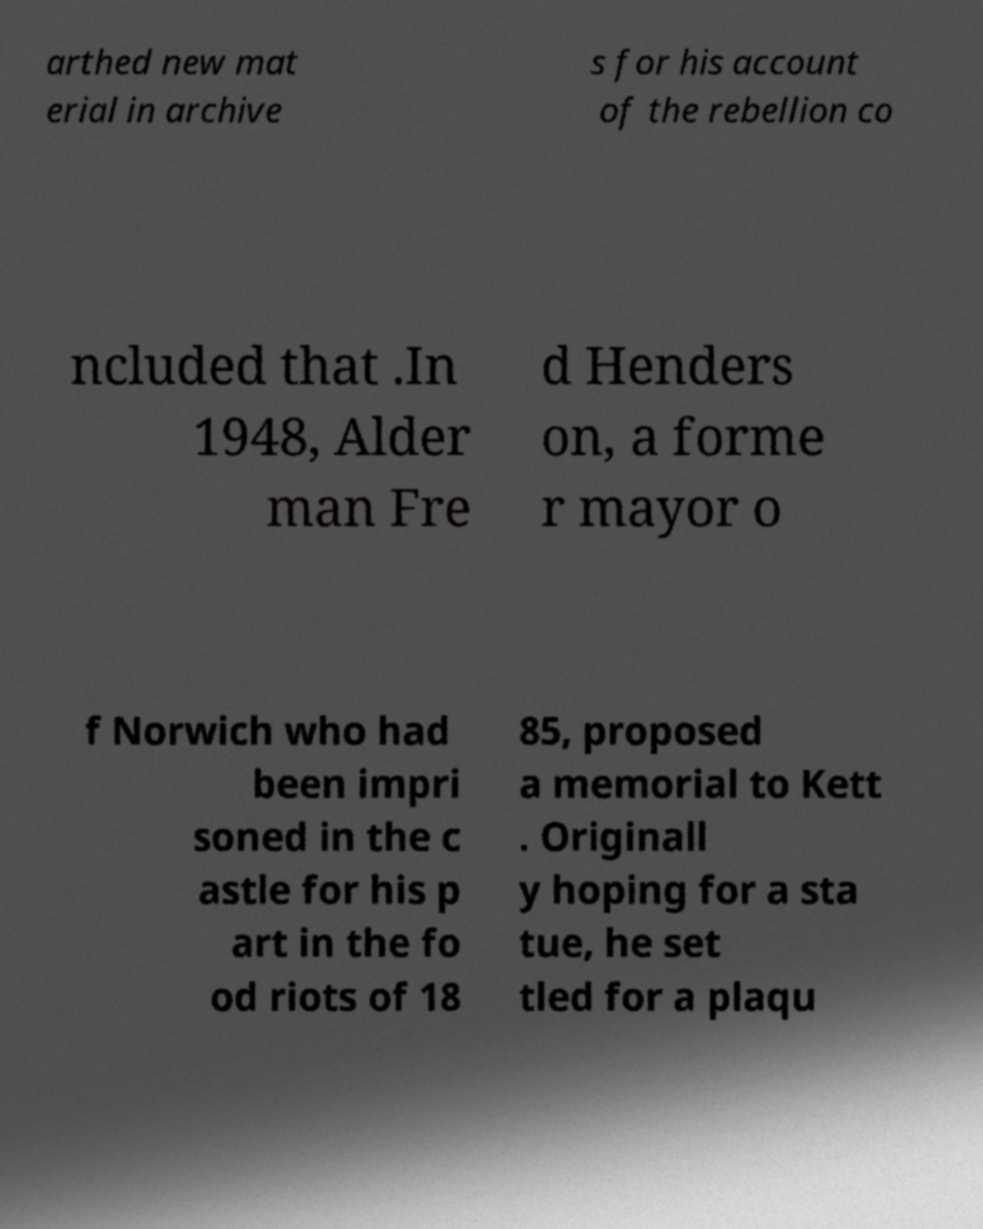Please read and relay the text visible in this image. What does it say? arthed new mat erial in archive s for his account of the rebellion co ncluded that .In 1948, Alder man Fre d Henders on, a forme r mayor o f Norwich who had been impri soned in the c astle for his p art in the fo od riots of 18 85, proposed a memorial to Kett . Originall y hoping for a sta tue, he set tled for a plaqu 